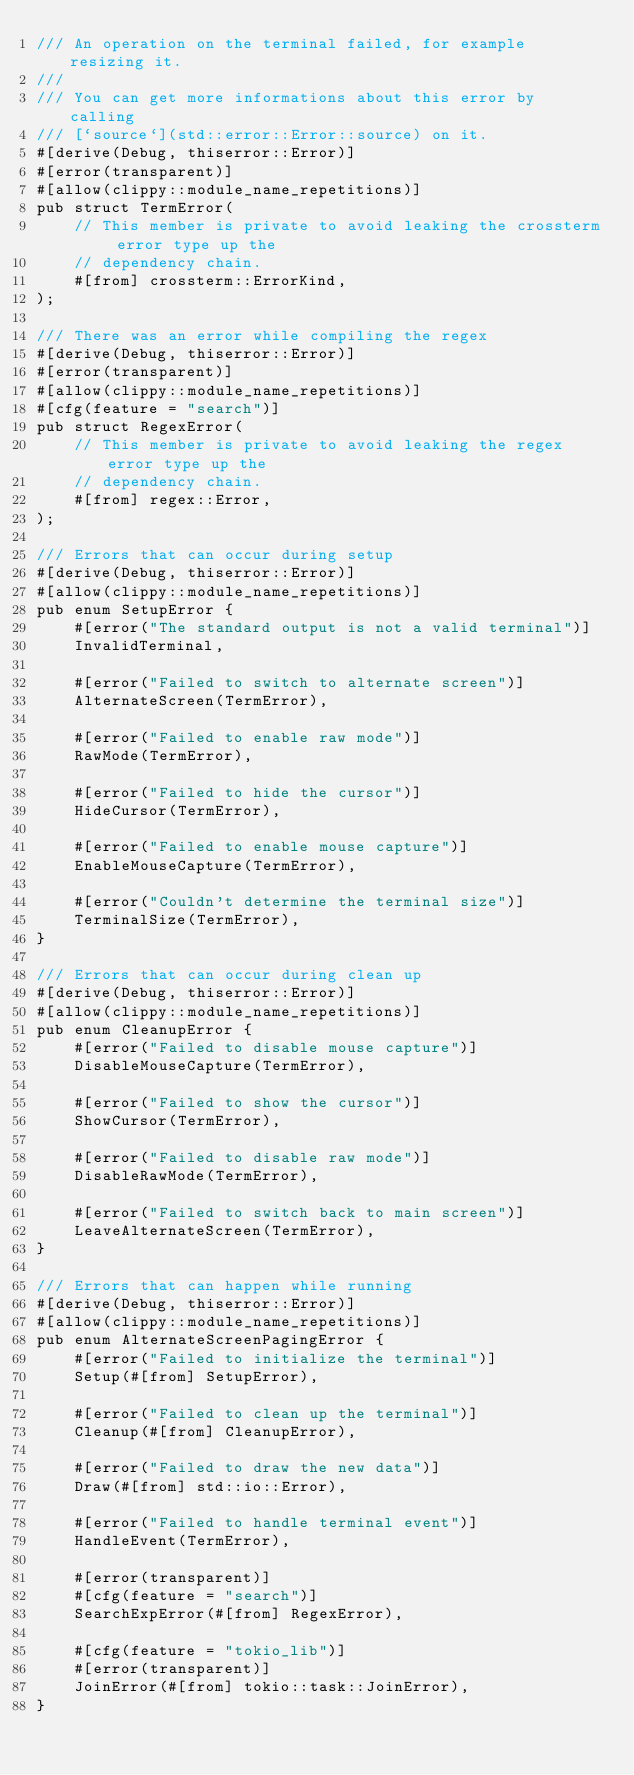<code> <loc_0><loc_0><loc_500><loc_500><_Rust_>/// An operation on the terminal failed, for example resizing it.
///
/// You can get more informations about this error by calling
/// [`source`](std::error::Error::source) on it.
#[derive(Debug, thiserror::Error)]
#[error(transparent)]
#[allow(clippy::module_name_repetitions)]
pub struct TermError(
    // This member is private to avoid leaking the crossterm error type up the
    // dependency chain.
    #[from] crossterm::ErrorKind,
);

/// There was an error while compiling the regex
#[derive(Debug, thiserror::Error)]
#[error(transparent)]
#[allow(clippy::module_name_repetitions)]
#[cfg(feature = "search")]
pub struct RegexError(
    // This member is private to avoid leaking the regex error type up the
    // dependency chain.
    #[from] regex::Error,
);

/// Errors that can occur during setup
#[derive(Debug, thiserror::Error)]
#[allow(clippy::module_name_repetitions)]
pub enum SetupError {
    #[error("The standard output is not a valid terminal")]
    InvalidTerminal,

    #[error("Failed to switch to alternate screen")]
    AlternateScreen(TermError),

    #[error("Failed to enable raw mode")]
    RawMode(TermError),

    #[error("Failed to hide the cursor")]
    HideCursor(TermError),

    #[error("Failed to enable mouse capture")]
    EnableMouseCapture(TermError),

    #[error("Couldn't determine the terminal size")]
    TerminalSize(TermError),
}

/// Errors that can occur during clean up
#[derive(Debug, thiserror::Error)]
#[allow(clippy::module_name_repetitions)]
pub enum CleanupError {
    #[error("Failed to disable mouse capture")]
    DisableMouseCapture(TermError),

    #[error("Failed to show the cursor")]
    ShowCursor(TermError),

    #[error("Failed to disable raw mode")]
    DisableRawMode(TermError),

    #[error("Failed to switch back to main screen")]
    LeaveAlternateScreen(TermError),
}

/// Errors that can happen while running
#[derive(Debug, thiserror::Error)]
#[allow(clippy::module_name_repetitions)]
pub enum AlternateScreenPagingError {
    #[error("Failed to initialize the terminal")]
    Setup(#[from] SetupError),

    #[error("Failed to clean up the terminal")]
    Cleanup(#[from] CleanupError),

    #[error("Failed to draw the new data")]
    Draw(#[from] std::io::Error),

    #[error("Failed to handle terminal event")]
    HandleEvent(TermError),

    #[error(transparent)]
    #[cfg(feature = "search")]
    SearchExpError(#[from] RegexError),

    #[cfg(feature = "tokio_lib")]
    #[error(transparent)]
    JoinError(#[from] tokio::task::JoinError),
}
</code> 